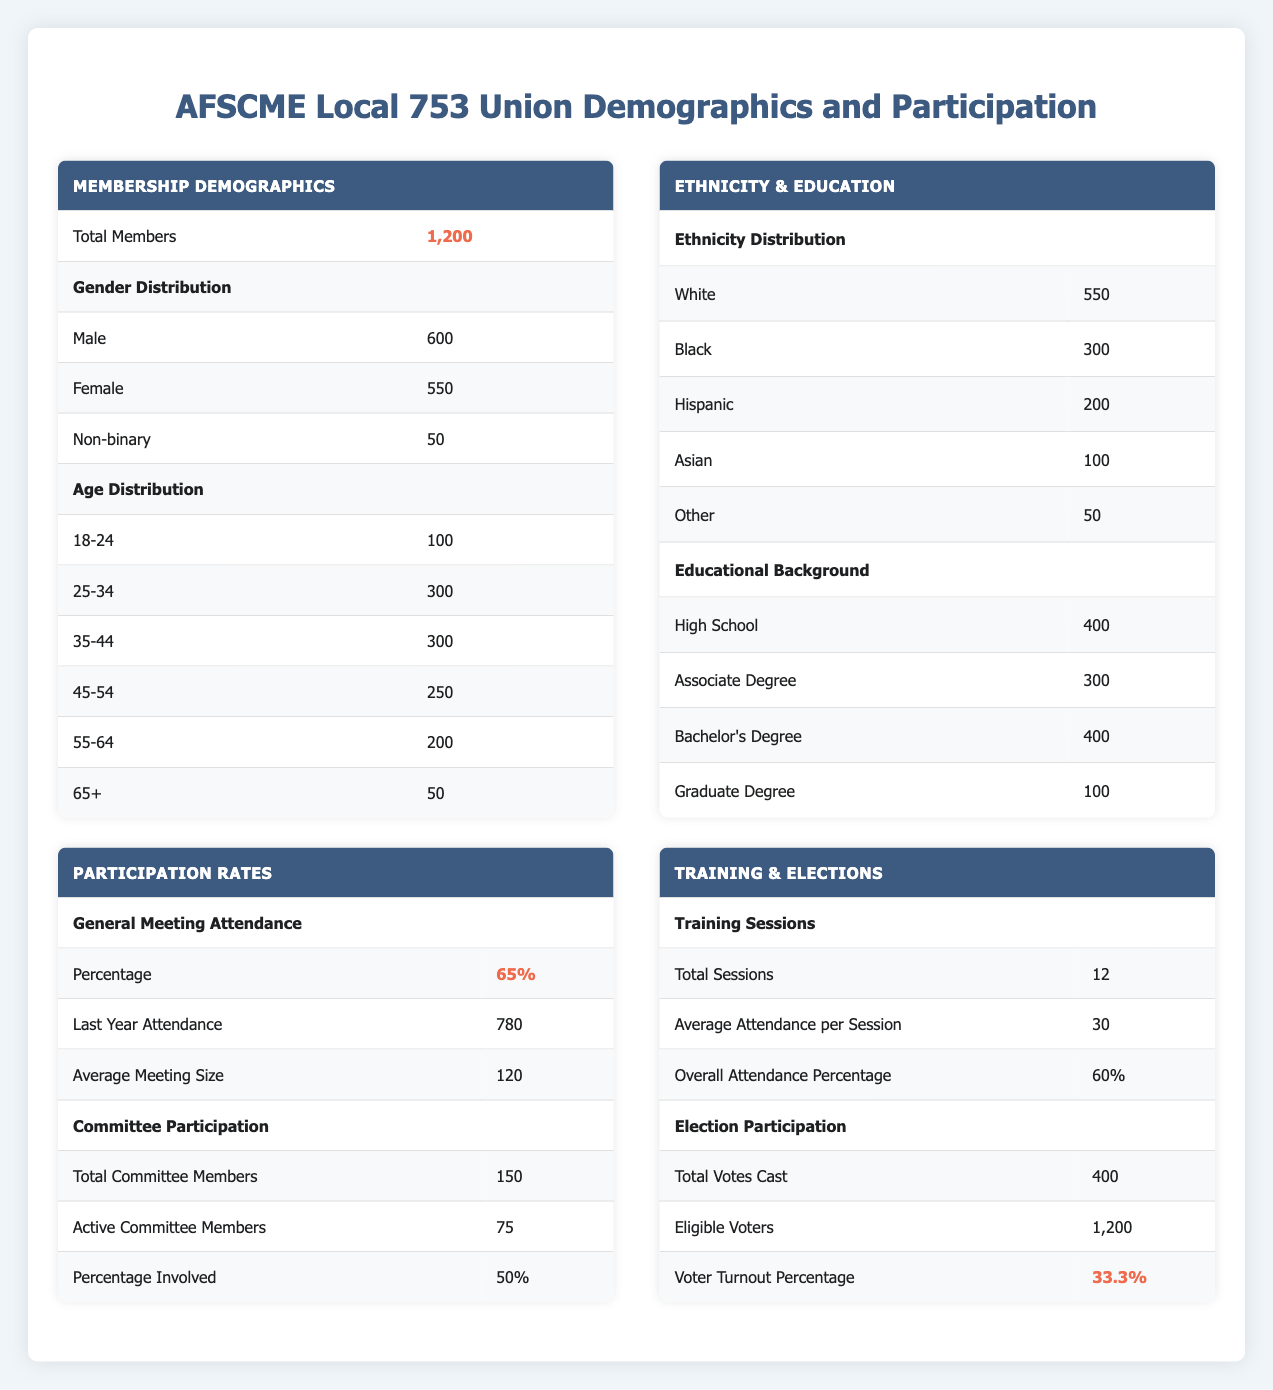What is the total number of members in AFSCME Local 753? The total number of members is explicitly stated in the table under "Total Members," which shows 1,200 members.
Answer: 1200 How many females are members of AFSCME Local 753? The number of female members is located in the table under the "Gender Distribution" section, where 550 female members are listed.
Answer: 550 What is the average age range of members who are 25-34 years old? Looking at the "Age Distribution" section, there are 300 members in the age range of 25-34, but the average age is not directly given. Thus, we take this as the specific member count rather than an average age.
Answer: 300 Is the percentage of male members higher than that of female members? The male members count is 600 and female members count is 550. Thus, we can conclude that yes, the percentage of male members is higher than female members as there are more male members.
Answer: Yes What is the total of members who have at least a bachelor’s degree? To find this, we sum up the members with a Bachelor's degree (400) and Graduate degree (100). So, 400 + 100 = 500 members hold at least a bachelor's degree.
Answer: 500 What percentage of AFSCME Local 753 members attended the most recent general meeting? The attendance for the last year is 780, and the total membership is 1,200. To find the percentage, we calculate (780/1200) * 100 = 65%.
Answer: 65% How many members are involved in committees compared to those who are not? There are a total of 150 committee members in the union. Thus, to find the non-member count, we subtract active members (75) from total members (1200) and then further assess that 150 members are committee members and subtract this from the total to get non-committee members. Thus, 1200 - 150 = 1050 (not involved in committee).
Answer: 150 involved (10.5%) What is the voter turnout percentage in the last election? The table indicates that the voter turnout percentage in the last election is stated as 33.3%. This value is drawn directly from the "Election Participation" section of the table.
Answer: 33.3% How many male members are aged 45 or above? To find this, we look at the age distribution. The age groups from 45-54 have 250 members, from 55-64 have 200 members, and those 65+ have 50 members, which totals to 250 + 200 + 50 = 500 members. Assuming no gender specification for age, this number can represent males among this age delineation, depending on previous distribution insights. However, a precise breakdown wasn't provided; thus, the specific count cannot be confirmed solely from the initial data.
Answer: Count not available without data 